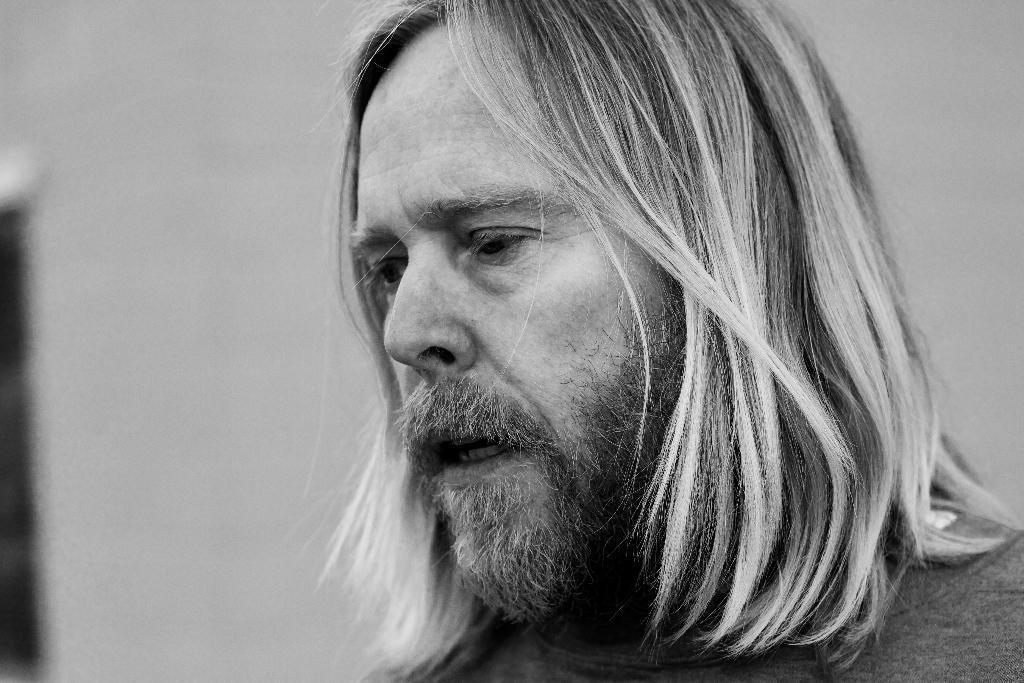Can you describe this image briefly? In this picture I can see a man in front and I see that this is a white and black picture. 